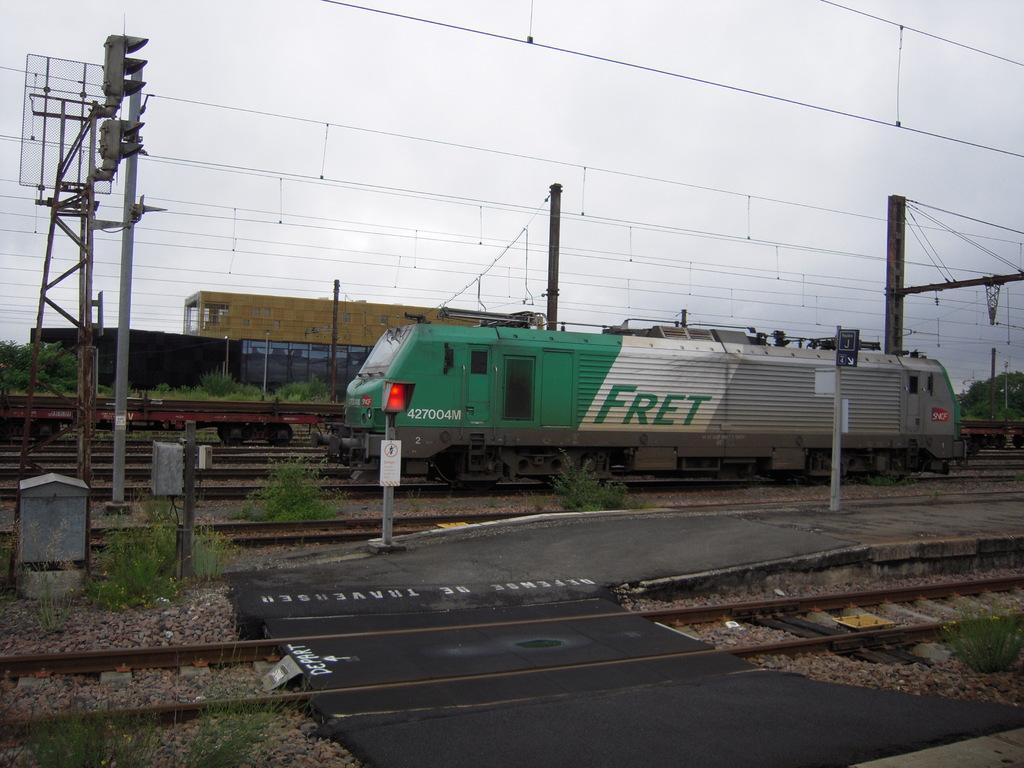<image>
Summarize the visual content of the image. A train has the Fret logo on the side in green lettering. 